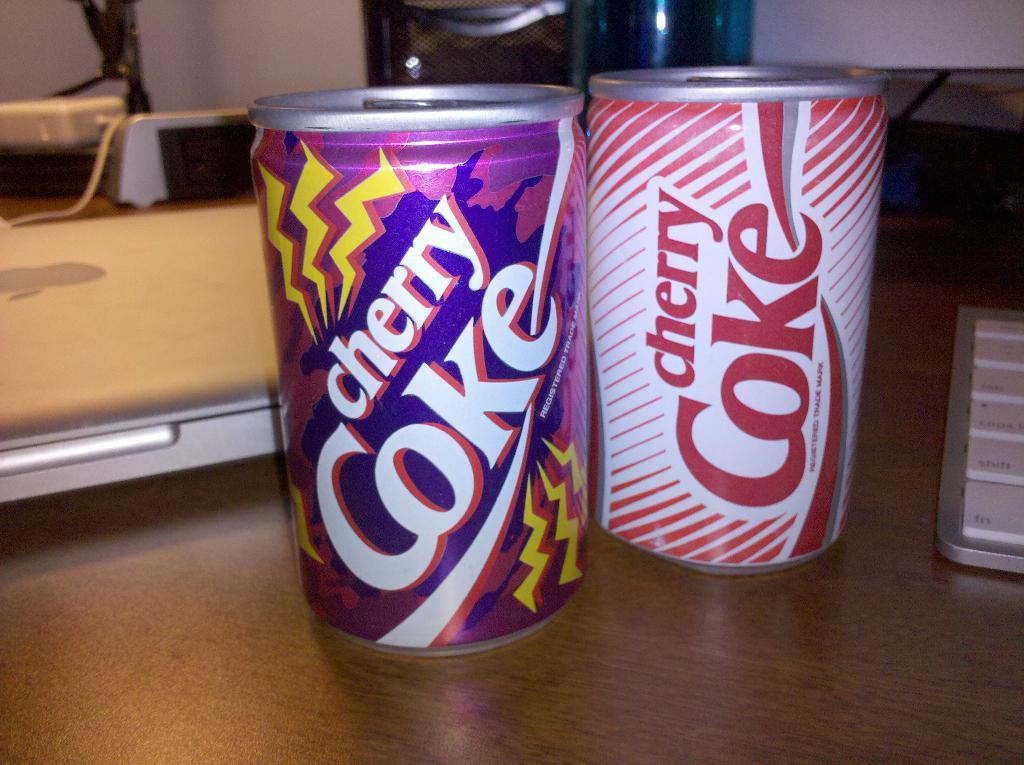What type of beverage containers are in the image? There are two coke tins in the image. What electronic device is in the image? There is a keyboard in the image. What other electronic device is in the image? There is a laptop in the image. Where are all of these objects located? All of these objects are on a table. What type of iron is visible in the image? There is no iron present in the image. How does the division between the two coke tins occur in the image? The image does not show a division between the two coke tins; they are simply placed next to each other. 